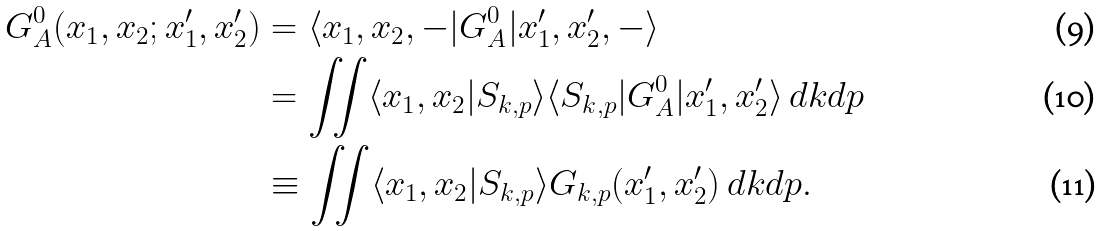Convert formula to latex. <formula><loc_0><loc_0><loc_500><loc_500>G ^ { 0 } _ { A } ( x _ { 1 } , x _ { 2 } ; x _ { 1 } ^ { \prime } , x _ { 2 } ^ { \prime } ) & = \langle x _ { 1 } , x _ { 2 } , - | G ^ { 0 } _ { A } | x _ { 1 } ^ { \prime } , x _ { 2 } ^ { \prime } , - \rangle \\ & = \iint \langle x _ { 1 } , x _ { 2 } | S _ { k , p } \rangle \langle S _ { k , p } | G ^ { 0 } _ { A } | x _ { 1 } ^ { \prime } , x _ { 2 } ^ { \prime } \rangle \, d k d p \\ & \equiv \iint \langle x _ { 1 } , x _ { 2 } | S _ { k , p } \rangle G _ { k , p } ( x _ { 1 } ^ { \prime } , x _ { 2 } ^ { \prime } ) \, d k d p .</formula> 